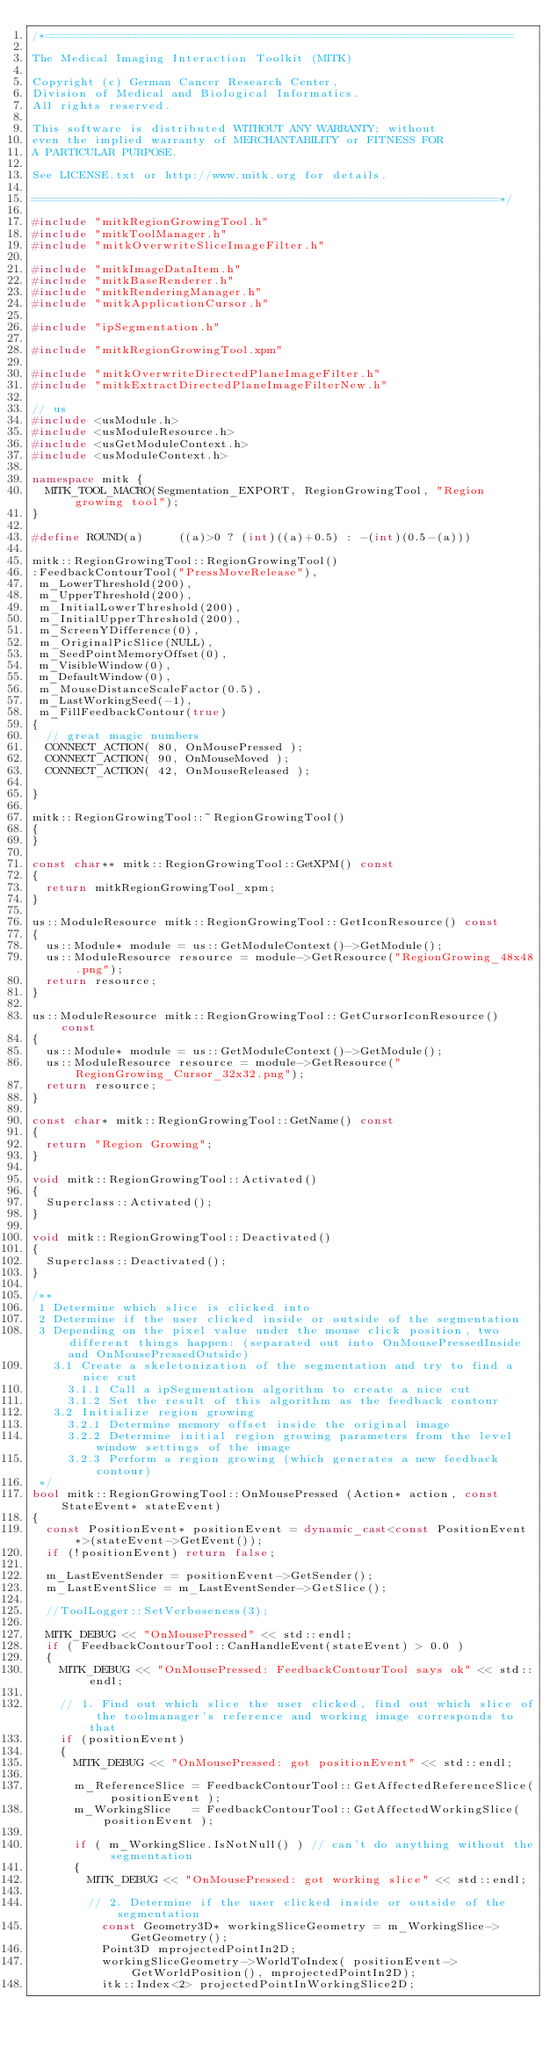<code> <loc_0><loc_0><loc_500><loc_500><_C++_>/*===================================================================

The Medical Imaging Interaction Toolkit (MITK)

Copyright (c) German Cancer Research Center,
Division of Medical and Biological Informatics.
All rights reserved.

This software is distributed WITHOUT ANY WARRANTY; without
even the implied warranty of MERCHANTABILITY or FITNESS FOR
A PARTICULAR PURPOSE.

See LICENSE.txt or http://www.mitk.org for details.

===================================================================*/

#include "mitkRegionGrowingTool.h"
#include "mitkToolManager.h"
#include "mitkOverwriteSliceImageFilter.h"

#include "mitkImageDataItem.h"
#include "mitkBaseRenderer.h"
#include "mitkRenderingManager.h"
#include "mitkApplicationCursor.h"

#include "ipSegmentation.h"

#include "mitkRegionGrowingTool.xpm"

#include "mitkOverwriteDirectedPlaneImageFilter.h"
#include "mitkExtractDirectedPlaneImageFilterNew.h"

// us
#include <usModule.h>
#include <usModuleResource.h>
#include <usGetModuleContext.h>
#include <usModuleContext.h>

namespace mitk {
  MITK_TOOL_MACRO(Segmentation_EXPORT, RegionGrowingTool, "Region growing tool");
}

#define ROUND(a)     ((a)>0 ? (int)((a)+0.5) : -(int)(0.5-(a)))

mitk::RegionGrowingTool::RegionGrowingTool()
:FeedbackContourTool("PressMoveRelease"),
 m_LowerThreshold(200),
 m_UpperThreshold(200),
 m_InitialLowerThreshold(200),
 m_InitialUpperThreshold(200),
 m_ScreenYDifference(0),
 m_OriginalPicSlice(NULL),
 m_SeedPointMemoryOffset(0),
 m_VisibleWindow(0),
 m_DefaultWindow(0),
 m_MouseDistanceScaleFactor(0.5),
 m_LastWorkingSeed(-1),
 m_FillFeedbackContour(true)
{
  // great magic numbers
  CONNECT_ACTION( 80, OnMousePressed );
  CONNECT_ACTION( 90, OnMouseMoved );
  CONNECT_ACTION( 42, OnMouseReleased );

}

mitk::RegionGrowingTool::~RegionGrowingTool()
{
}

const char** mitk::RegionGrowingTool::GetXPM() const
{
  return mitkRegionGrowingTool_xpm;
}

us::ModuleResource mitk::RegionGrowingTool::GetIconResource() const
{
  us::Module* module = us::GetModuleContext()->GetModule();
  us::ModuleResource resource = module->GetResource("RegionGrowing_48x48.png");
  return resource;
}

us::ModuleResource mitk::RegionGrowingTool::GetCursorIconResource() const
{
  us::Module* module = us::GetModuleContext()->GetModule();
  us::ModuleResource resource = module->GetResource("RegionGrowing_Cursor_32x32.png");
  return resource;
}

const char* mitk::RegionGrowingTool::GetName() const
{
  return "Region Growing";
}

void mitk::RegionGrowingTool::Activated()
{
  Superclass::Activated();
}

void mitk::RegionGrowingTool::Deactivated()
{
  Superclass::Deactivated();
}

/**
 1 Determine which slice is clicked into
 2 Determine if the user clicked inside or outside of the segmentation
 3 Depending on the pixel value under the mouse click position, two different things happen: (separated out into OnMousePressedInside and OnMousePressedOutside)
   3.1 Create a skeletonization of the segmentation and try to find a nice cut
     3.1.1 Call a ipSegmentation algorithm to create a nice cut
     3.1.2 Set the result of this algorithm as the feedback contour
   3.2 Initialize region growing
     3.2.1 Determine memory offset inside the original image
     3.2.2 Determine initial region growing parameters from the level window settings of the image
     3.2.3 Perform a region growing (which generates a new feedback contour)
 */
bool mitk::RegionGrowingTool::OnMousePressed (Action* action, const StateEvent* stateEvent)
{
  const PositionEvent* positionEvent = dynamic_cast<const PositionEvent*>(stateEvent->GetEvent());
  if (!positionEvent) return false;

  m_LastEventSender = positionEvent->GetSender();
  m_LastEventSlice = m_LastEventSender->GetSlice();

  //ToolLogger::SetVerboseness(3);

  MITK_DEBUG << "OnMousePressed" << std::endl;
  if ( FeedbackContourTool::CanHandleEvent(stateEvent) > 0.0 )
  {
    MITK_DEBUG << "OnMousePressed: FeedbackContourTool says ok" << std::endl;

    // 1. Find out which slice the user clicked, find out which slice of the toolmanager's reference and working image corresponds to that
    if (positionEvent)
    {
      MITK_DEBUG << "OnMousePressed: got positionEvent" << std::endl;

      m_ReferenceSlice = FeedbackContourTool::GetAffectedReferenceSlice( positionEvent );
      m_WorkingSlice   = FeedbackContourTool::GetAffectedWorkingSlice( positionEvent );

      if ( m_WorkingSlice.IsNotNull() ) // can't do anything without the segmentation
      {
        MITK_DEBUG << "OnMousePressed: got working slice" << std::endl;

        // 2. Determine if the user clicked inside or outside of the segmentation
          const Geometry3D* workingSliceGeometry = m_WorkingSlice->GetGeometry();
          Point3D mprojectedPointIn2D;
          workingSliceGeometry->WorldToIndex( positionEvent->GetWorldPosition(), mprojectedPointIn2D);
          itk::Index<2> projectedPointInWorkingSlice2D;</code> 